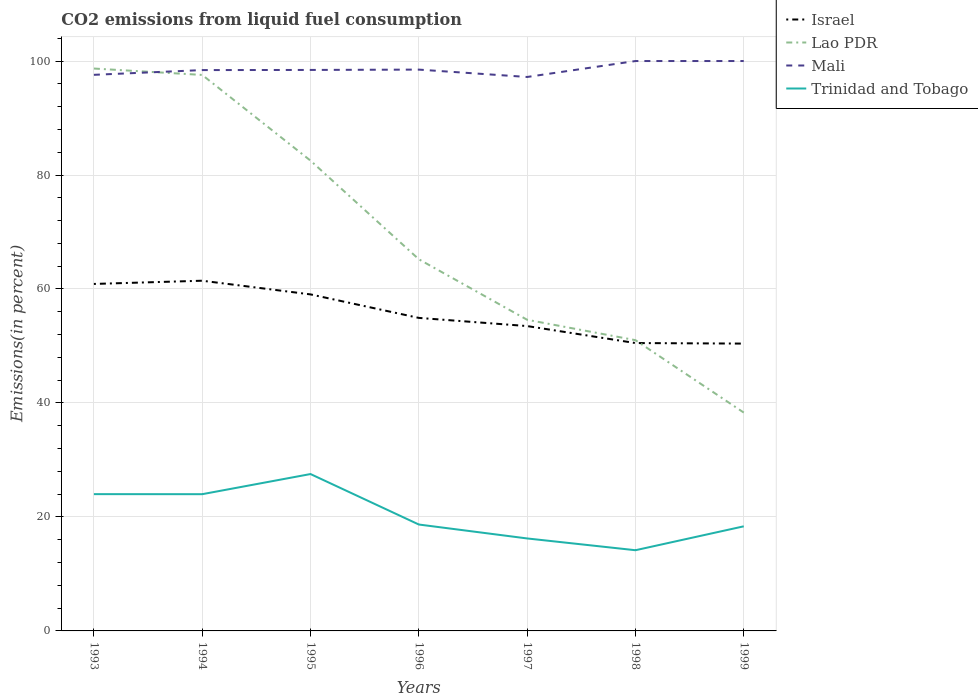How many different coloured lines are there?
Your answer should be very brief. 4. Is the number of lines equal to the number of legend labels?
Keep it short and to the point. Yes. Across all years, what is the maximum total CO2 emitted in Israel?
Provide a succinct answer. 50.42. What is the total total CO2 emitted in Lao PDR in the graph?
Give a very brief answer. 60.37. What is the difference between the highest and the second highest total CO2 emitted in Israel?
Give a very brief answer. 11.03. What is the difference between the highest and the lowest total CO2 emitted in Mali?
Offer a terse response. 2. Is the total CO2 emitted in Lao PDR strictly greater than the total CO2 emitted in Trinidad and Tobago over the years?
Offer a very short reply. No. How many lines are there?
Give a very brief answer. 4. What is the difference between two consecutive major ticks on the Y-axis?
Offer a terse response. 20. Does the graph contain grids?
Provide a succinct answer. Yes. What is the title of the graph?
Your answer should be very brief. CO2 emissions from liquid fuel consumption. Does "Faeroe Islands" appear as one of the legend labels in the graph?
Provide a succinct answer. No. What is the label or title of the Y-axis?
Give a very brief answer. Emissions(in percent). What is the Emissions(in percent) in Israel in 1993?
Your answer should be very brief. 60.89. What is the Emissions(in percent) in Lao PDR in 1993?
Provide a short and direct response. 98.68. What is the Emissions(in percent) in Mali in 1993?
Keep it short and to the point. 97.58. What is the Emissions(in percent) in Trinidad and Tobago in 1993?
Provide a short and direct response. 24. What is the Emissions(in percent) in Israel in 1994?
Give a very brief answer. 61.45. What is the Emissions(in percent) of Lao PDR in 1994?
Your response must be concise. 97.56. What is the Emissions(in percent) of Mali in 1994?
Give a very brief answer. 98.41. What is the Emissions(in percent) in Trinidad and Tobago in 1994?
Offer a very short reply. 23.99. What is the Emissions(in percent) of Israel in 1995?
Give a very brief answer. 59.05. What is the Emissions(in percent) in Lao PDR in 1995?
Keep it short and to the point. 82.52. What is the Emissions(in percent) of Mali in 1995?
Offer a terse response. 98.44. What is the Emissions(in percent) of Trinidad and Tobago in 1995?
Provide a succinct answer. 27.53. What is the Emissions(in percent) of Israel in 1996?
Make the answer very short. 54.93. What is the Emissions(in percent) of Lao PDR in 1996?
Your answer should be very brief. 65.22. What is the Emissions(in percent) in Mali in 1996?
Ensure brevity in your answer.  98.5. What is the Emissions(in percent) in Trinidad and Tobago in 1996?
Offer a very short reply. 18.67. What is the Emissions(in percent) in Israel in 1997?
Give a very brief answer. 53.49. What is the Emissions(in percent) in Lao PDR in 1997?
Offer a terse response. 54.6. What is the Emissions(in percent) of Mali in 1997?
Ensure brevity in your answer.  97.2. What is the Emissions(in percent) of Trinidad and Tobago in 1997?
Offer a very short reply. 16.23. What is the Emissions(in percent) of Israel in 1998?
Ensure brevity in your answer.  50.51. What is the Emissions(in percent) in Lao PDR in 1998?
Offer a terse response. 51.02. What is the Emissions(in percent) in Mali in 1998?
Your response must be concise. 100. What is the Emissions(in percent) of Trinidad and Tobago in 1998?
Provide a short and direct response. 14.16. What is the Emissions(in percent) in Israel in 1999?
Ensure brevity in your answer.  50.42. What is the Emissions(in percent) in Lao PDR in 1999?
Make the answer very short. 38.31. What is the Emissions(in percent) of Trinidad and Tobago in 1999?
Your response must be concise. 18.35. Across all years, what is the maximum Emissions(in percent) in Israel?
Provide a short and direct response. 61.45. Across all years, what is the maximum Emissions(in percent) of Lao PDR?
Your answer should be compact. 98.68. Across all years, what is the maximum Emissions(in percent) of Trinidad and Tobago?
Give a very brief answer. 27.53. Across all years, what is the minimum Emissions(in percent) in Israel?
Provide a succinct answer. 50.42. Across all years, what is the minimum Emissions(in percent) of Lao PDR?
Your answer should be compact. 38.31. Across all years, what is the minimum Emissions(in percent) of Mali?
Your response must be concise. 97.2. Across all years, what is the minimum Emissions(in percent) in Trinidad and Tobago?
Keep it short and to the point. 14.16. What is the total Emissions(in percent) of Israel in the graph?
Provide a succinct answer. 390.74. What is the total Emissions(in percent) in Lao PDR in the graph?
Provide a succinct answer. 487.92. What is the total Emissions(in percent) of Mali in the graph?
Give a very brief answer. 690.13. What is the total Emissions(in percent) of Trinidad and Tobago in the graph?
Provide a short and direct response. 142.94. What is the difference between the Emissions(in percent) of Israel in 1993 and that in 1994?
Your answer should be compact. -0.57. What is the difference between the Emissions(in percent) in Lao PDR in 1993 and that in 1994?
Your answer should be compact. 1.12. What is the difference between the Emissions(in percent) of Mali in 1993 and that in 1994?
Keep it short and to the point. -0.83. What is the difference between the Emissions(in percent) of Trinidad and Tobago in 1993 and that in 1994?
Provide a short and direct response. 0.01. What is the difference between the Emissions(in percent) of Israel in 1993 and that in 1995?
Keep it short and to the point. 1.83. What is the difference between the Emissions(in percent) of Lao PDR in 1993 and that in 1995?
Provide a short and direct response. 16.16. What is the difference between the Emissions(in percent) of Mali in 1993 and that in 1995?
Provide a succinct answer. -0.86. What is the difference between the Emissions(in percent) of Trinidad and Tobago in 1993 and that in 1995?
Offer a terse response. -3.52. What is the difference between the Emissions(in percent) of Israel in 1993 and that in 1996?
Ensure brevity in your answer.  5.96. What is the difference between the Emissions(in percent) in Lao PDR in 1993 and that in 1996?
Your answer should be very brief. 33.47. What is the difference between the Emissions(in percent) of Mali in 1993 and that in 1996?
Keep it short and to the point. -0.92. What is the difference between the Emissions(in percent) of Trinidad and Tobago in 1993 and that in 1996?
Offer a terse response. 5.33. What is the difference between the Emissions(in percent) of Israel in 1993 and that in 1997?
Offer a very short reply. 7.39. What is the difference between the Emissions(in percent) in Lao PDR in 1993 and that in 1997?
Offer a very short reply. 44.09. What is the difference between the Emissions(in percent) in Mali in 1993 and that in 1997?
Offer a very short reply. 0.38. What is the difference between the Emissions(in percent) of Trinidad and Tobago in 1993 and that in 1997?
Give a very brief answer. 7.77. What is the difference between the Emissions(in percent) in Israel in 1993 and that in 1998?
Provide a short and direct response. 10.37. What is the difference between the Emissions(in percent) in Lao PDR in 1993 and that in 1998?
Offer a terse response. 47.66. What is the difference between the Emissions(in percent) of Mali in 1993 and that in 1998?
Your answer should be compact. -2.42. What is the difference between the Emissions(in percent) of Trinidad and Tobago in 1993 and that in 1998?
Your answer should be very brief. 9.84. What is the difference between the Emissions(in percent) of Israel in 1993 and that in 1999?
Keep it short and to the point. 10.47. What is the difference between the Emissions(in percent) in Lao PDR in 1993 and that in 1999?
Keep it short and to the point. 60.37. What is the difference between the Emissions(in percent) in Mali in 1993 and that in 1999?
Keep it short and to the point. -2.42. What is the difference between the Emissions(in percent) of Trinidad and Tobago in 1993 and that in 1999?
Give a very brief answer. 5.65. What is the difference between the Emissions(in percent) of Israel in 1994 and that in 1995?
Your answer should be compact. 2.4. What is the difference between the Emissions(in percent) of Lao PDR in 1994 and that in 1995?
Make the answer very short. 15.04. What is the difference between the Emissions(in percent) in Mali in 1994 and that in 1995?
Provide a succinct answer. -0.02. What is the difference between the Emissions(in percent) of Trinidad and Tobago in 1994 and that in 1995?
Provide a succinct answer. -3.53. What is the difference between the Emissions(in percent) of Israel in 1994 and that in 1996?
Keep it short and to the point. 6.52. What is the difference between the Emissions(in percent) in Lao PDR in 1994 and that in 1996?
Provide a short and direct response. 32.34. What is the difference between the Emissions(in percent) of Mali in 1994 and that in 1996?
Provide a short and direct response. -0.08. What is the difference between the Emissions(in percent) of Trinidad and Tobago in 1994 and that in 1996?
Your answer should be very brief. 5.32. What is the difference between the Emissions(in percent) of Israel in 1994 and that in 1997?
Your answer should be compact. 7.96. What is the difference between the Emissions(in percent) of Lao PDR in 1994 and that in 1997?
Offer a terse response. 42.96. What is the difference between the Emissions(in percent) in Mali in 1994 and that in 1997?
Make the answer very short. 1.21. What is the difference between the Emissions(in percent) of Trinidad and Tobago in 1994 and that in 1997?
Offer a terse response. 7.77. What is the difference between the Emissions(in percent) in Israel in 1994 and that in 1998?
Ensure brevity in your answer.  10.94. What is the difference between the Emissions(in percent) of Lao PDR in 1994 and that in 1998?
Your answer should be very brief. 46.54. What is the difference between the Emissions(in percent) of Mali in 1994 and that in 1998?
Keep it short and to the point. -1.59. What is the difference between the Emissions(in percent) of Trinidad and Tobago in 1994 and that in 1998?
Give a very brief answer. 9.83. What is the difference between the Emissions(in percent) in Israel in 1994 and that in 1999?
Offer a very short reply. 11.03. What is the difference between the Emissions(in percent) of Lao PDR in 1994 and that in 1999?
Provide a short and direct response. 59.25. What is the difference between the Emissions(in percent) in Mali in 1994 and that in 1999?
Provide a short and direct response. -1.59. What is the difference between the Emissions(in percent) in Trinidad and Tobago in 1994 and that in 1999?
Give a very brief answer. 5.64. What is the difference between the Emissions(in percent) of Israel in 1995 and that in 1996?
Give a very brief answer. 4.12. What is the difference between the Emissions(in percent) in Lao PDR in 1995 and that in 1996?
Keep it short and to the point. 17.31. What is the difference between the Emissions(in percent) in Mali in 1995 and that in 1996?
Give a very brief answer. -0.06. What is the difference between the Emissions(in percent) in Trinidad and Tobago in 1995 and that in 1996?
Make the answer very short. 8.86. What is the difference between the Emissions(in percent) in Israel in 1995 and that in 1997?
Give a very brief answer. 5.56. What is the difference between the Emissions(in percent) in Lao PDR in 1995 and that in 1997?
Offer a very short reply. 27.93. What is the difference between the Emissions(in percent) in Mali in 1995 and that in 1997?
Offer a very short reply. 1.23. What is the difference between the Emissions(in percent) of Trinidad and Tobago in 1995 and that in 1997?
Your response must be concise. 11.3. What is the difference between the Emissions(in percent) in Israel in 1995 and that in 1998?
Your response must be concise. 8.54. What is the difference between the Emissions(in percent) of Lao PDR in 1995 and that in 1998?
Provide a short and direct response. 31.5. What is the difference between the Emissions(in percent) of Mali in 1995 and that in 1998?
Provide a succinct answer. -1.56. What is the difference between the Emissions(in percent) of Trinidad and Tobago in 1995 and that in 1998?
Keep it short and to the point. 13.37. What is the difference between the Emissions(in percent) of Israel in 1995 and that in 1999?
Offer a very short reply. 8.63. What is the difference between the Emissions(in percent) in Lao PDR in 1995 and that in 1999?
Your answer should be compact. 44.21. What is the difference between the Emissions(in percent) of Mali in 1995 and that in 1999?
Your answer should be compact. -1.56. What is the difference between the Emissions(in percent) of Trinidad and Tobago in 1995 and that in 1999?
Ensure brevity in your answer.  9.17. What is the difference between the Emissions(in percent) of Israel in 1996 and that in 1997?
Give a very brief answer. 1.43. What is the difference between the Emissions(in percent) in Lao PDR in 1996 and that in 1997?
Provide a short and direct response. 10.62. What is the difference between the Emissions(in percent) of Mali in 1996 and that in 1997?
Keep it short and to the point. 1.29. What is the difference between the Emissions(in percent) in Trinidad and Tobago in 1996 and that in 1997?
Provide a succinct answer. 2.44. What is the difference between the Emissions(in percent) in Israel in 1996 and that in 1998?
Your response must be concise. 4.41. What is the difference between the Emissions(in percent) in Lao PDR in 1996 and that in 1998?
Keep it short and to the point. 14.2. What is the difference between the Emissions(in percent) in Mali in 1996 and that in 1998?
Offer a very short reply. -1.5. What is the difference between the Emissions(in percent) in Trinidad and Tobago in 1996 and that in 1998?
Provide a succinct answer. 4.51. What is the difference between the Emissions(in percent) in Israel in 1996 and that in 1999?
Ensure brevity in your answer.  4.51. What is the difference between the Emissions(in percent) of Lao PDR in 1996 and that in 1999?
Make the answer very short. 26.9. What is the difference between the Emissions(in percent) of Mali in 1996 and that in 1999?
Provide a short and direct response. -1.5. What is the difference between the Emissions(in percent) of Trinidad and Tobago in 1996 and that in 1999?
Provide a succinct answer. 0.32. What is the difference between the Emissions(in percent) in Israel in 1997 and that in 1998?
Give a very brief answer. 2.98. What is the difference between the Emissions(in percent) of Lao PDR in 1997 and that in 1998?
Provide a short and direct response. 3.58. What is the difference between the Emissions(in percent) of Mali in 1997 and that in 1998?
Make the answer very short. -2.8. What is the difference between the Emissions(in percent) of Trinidad and Tobago in 1997 and that in 1998?
Keep it short and to the point. 2.07. What is the difference between the Emissions(in percent) of Israel in 1997 and that in 1999?
Ensure brevity in your answer.  3.08. What is the difference between the Emissions(in percent) in Lao PDR in 1997 and that in 1999?
Provide a succinct answer. 16.28. What is the difference between the Emissions(in percent) of Mali in 1997 and that in 1999?
Your answer should be compact. -2.8. What is the difference between the Emissions(in percent) of Trinidad and Tobago in 1997 and that in 1999?
Your answer should be very brief. -2.13. What is the difference between the Emissions(in percent) of Israel in 1998 and that in 1999?
Keep it short and to the point. 0.1. What is the difference between the Emissions(in percent) of Lao PDR in 1998 and that in 1999?
Provide a succinct answer. 12.71. What is the difference between the Emissions(in percent) in Trinidad and Tobago in 1998 and that in 1999?
Provide a succinct answer. -4.19. What is the difference between the Emissions(in percent) of Israel in 1993 and the Emissions(in percent) of Lao PDR in 1994?
Ensure brevity in your answer.  -36.68. What is the difference between the Emissions(in percent) of Israel in 1993 and the Emissions(in percent) of Mali in 1994?
Your response must be concise. -37.53. What is the difference between the Emissions(in percent) in Israel in 1993 and the Emissions(in percent) in Trinidad and Tobago in 1994?
Offer a terse response. 36.89. What is the difference between the Emissions(in percent) of Lao PDR in 1993 and the Emissions(in percent) of Mali in 1994?
Provide a short and direct response. 0.27. What is the difference between the Emissions(in percent) in Lao PDR in 1993 and the Emissions(in percent) in Trinidad and Tobago in 1994?
Ensure brevity in your answer.  74.69. What is the difference between the Emissions(in percent) in Mali in 1993 and the Emissions(in percent) in Trinidad and Tobago in 1994?
Give a very brief answer. 73.59. What is the difference between the Emissions(in percent) of Israel in 1993 and the Emissions(in percent) of Lao PDR in 1995?
Provide a short and direct response. -21.64. What is the difference between the Emissions(in percent) in Israel in 1993 and the Emissions(in percent) in Mali in 1995?
Your answer should be compact. -37.55. What is the difference between the Emissions(in percent) of Israel in 1993 and the Emissions(in percent) of Trinidad and Tobago in 1995?
Offer a very short reply. 33.36. What is the difference between the Emissions(in percent) in Lao PDR in 1993 and the Emissions(in percent) in Mali in 1995?
Offer a terse response. 0.25. What is the difference between the Emissions(in percent) of Lao PDR in 1993 and the Emissions(in percent) of Trinidad and Tobago in 1995?
Provide a succinct answer. 71.16. What is the difference between the Emissions(in percent) in Mali in 1993 and the Emissions(in percent) in Trinidad and Tobago in 1995?
Keep it short and to the point. 70.05. What is the difference between the Emissions(in percent) in Israel in 1993 and the Emissions(in percent) in Lao PDR in 1996?
Offer a terse response. -4.33. What is the difference between the Emissions(in percent) of Israel in 1993 and the Emissions(in percent) of Mali in 1996?
Provide a succinct answer. -37.61. What is the difference between the Emissions(in percent) in Israel in 1993 and the Emissions(in percent) in Trinidad and Tobago in 1996?
Provide a short and direct response. 42.22. What is the difference between the Emissions(in percent) in Lao PDR in 1993 and the Emissions(in percent) in Mali in 1996?
Provide a short and direct response. 0.19. What is the difference between the Emissions(in percent) in Lao PDR in 1993 and the Emissions(in percent) in Trinidad and Tobago in 1996?
Provide a succinct answer. 80.01. What is the difference between the Emissions(in percent) in Mali in 1993 and the Emissions(in percent) in Trinidad and Tobago in 1996?
Keep it short and to the point. 78.91. What is the difference between the Emissions(in percent) of Israel in 1993 and the Emissions(in percent) of Lao PDR in 1997?
Make the answer very short. 6.29. What is the difference between the Emissions(in percent) in Israel in 1993 and the Emissions(in percent) in Mali in 1997?
Keep it short and to the point. -36.32. What is the difference between the Emissions(in percent) of Israel in 1993 and the Emissions(in percent) of Trinidad and Tobago in 1997?
Offer a very short reply. 44.66. What is the difference between the Emissions(in percent) in Lao PDR in 1993 and the Emissions(in percent) in Mali in 1997?
Your response must be concise. 1.48. What is the difference between the Emissions(in percent) of Lao PDR in 1993 and the Emissions(in percent) of Trinidad and Tobago in 1997?
Keep it short and to the point. 82.46. What is the difference between the Emissions(in percent) of Mali in 1993 and the Emissions(in percent) of Trinidad and Tobago in 1997?
Make the answer very short. 81.35. What is the difference between the Emissions(in percent) of Israel in 1993 and the Emissions(in percent) of Lao PDR in 1998?
Offer a terse response. 9.87. What is the difference between the Emissions(in percent) in Israel in 1993 and the Emissions(in percent) in Mali in 1998?
Your response must be concise. -39.11. What is the difference between the Emissions(in percent) of Israel in 1993 and the Emissions(in percent) of Trinidad and Tobago in 1998?
Provide a succinct answer. 46.72. What is the difference between the Emissions(in percent) in Lao PDR in 1993 and the Emissions(in percent) in Mali in 1998?
Your answer should be very brief. -1.32. What is the difference between the Emissions(in percent) in Lao PDR in 1993 and the Emissions(in percent) in Trinidad and Tobago in 1998?
Make the answer very short. 84.52. What is the difference between the Emissions(in percent) of Mali in 1993 and the Emissions(in percent) of Trinidad and Tobago in 1998?
Offer a very short reply. 83.42. What is the difference between the Emissions(in percent) of Israel in 1993 and the Emissions(in percent) of Lao PDR in 1999?
Provide a short and direct response. 22.57. What is the difference between the Emissions(in percent) in Israel in 1993 and the Emissions(in percent) in Mali in 1999?
Ensure brevity in your answer.  -39.11. What is the difference between the Emissions(in percent) of Israel in 1993 and the Emissions(in percent) of Trinidad and Tobago in 1999?
Offer a very short reply. 42.53. What is the difference between the Emissions(in percent) in Lao PDR in 1993 and the Emissions(in percent) in Mali in 1999?
Offer a terse response. -1.32. What is the difference between the Emissions(in percent) in Lao PDR in 1993 and the Emissions(in percent) in Trinidad and Tobago in 1999?
Keep it short and to the point. 80.33. What is the difference between the Emissions(in percent) of Mali in 1993 and the Emissions(in percent) of Trinidad and Tobago in 1999?
Make the answer very short. 79.23. What is the difference between the Emissions(in percent) in Israel in 1994 and the Emissions(in percent) in Lao PDR in 1995?
Ensure brevity in your answer.  -21.07. What is the difference between the Emissions(in percent) in Israel in 1994 and the Emissions(in percent) in Mali in 1995?
Keep it short and to the point. -36.99. What is the difference between the Emissions(in percent) in Israel in 1994 and the Emissions(in percent) in Trinidad and Tobago in 1995?
Provide a succinct answer. 33.92. What is the difference between the Emissions(in percent) in Lao PDR in 1994 and the Emissions(in percent) in Mali in 1995?
Your answer should be very brief. -0.88. What is the difference between the Emissions(in percent) in Lao PDR in 1994 and the Emissions(in percent) in Trinidad and Tobago in 1995?
Provide a succinct answer. 70.03. What is the difference between the Emissions(in percent) in Mali in 1994 and the Emissions(in percent) in Trinidad and Tobago in 1995?
Your answer should be very brief. 70.89. What is the difference between the Emissions(in percent) in Israel in 1994 and the Emissions(in percent) in Lao PDR in 1996?
Keep it short and to the point. -3.77. What is the difference between the Emissions(in percent) in Israel in 1994 and the Emissions(in percent) in Mali in 1996?
Offer a terse response. -37.04. What is the difference between the Emissions(in percent) of Israel in 1994 and the Emissions(in percent) of Trinidad and Tobago in 1996?
Keep it short and to the point. 42.78. What is the difference between the Emissions(in percent) of Lao PDR in 1994 and the Emissions(in percent) of Mali in 1996?
Give a very brief answer. -0.94. What is the difference between the Emissions(in percent) in Lao PDR in 1994 and the Emissions(in percent) in Trinidad and Tobago in 1996?
Your answer should be very brief. 78.89. What is the difference between the Emissions(in percent) in Mali in 1994 and the Emissions(in percent) in Trinidad and Tobago in 1996?
Ensure brevity in your answer.  79.74. What is the difference between the Emissions(in percent) in Israel in 1994 and the Emissions(in percent) in Lao PDR in 1997?
Ensure brevity in your answer.  6.85. What is the difference between the Emissions(in percent) of Israel in 1994 and the Emissions(in percent) of Mali in 1997?
Offer a very short reply. -35.75. What is the difference between the Emissions(in percent) of Israel in 1994 and the Emissions(in percent) of Trinidad and Tobago in 1997?
Provide a short and direct response. 45.22. What is the difference between the Emissions(in percent) of Lao PDR in 1994 and the Emissions(in percent) of Mali in 1997?
Give a very brief answer. 0.36. What is the difference between the Emissions(in percent) of Lao PDR in 1994 and the Emissions(in percent) of Trinidad and Tobago in 1997?
Your answer should be very brief. 81.33. What is the difference between the Emissions(in percent) of Mali in 1994 and the Emissions(in percent) of Trinidad and Tobago in 1997?
Ensure brevity in your answer.  82.18. What is the difference between the Emissions(in percent) in Israel in 1994 and the Emissions(in percent) in Lao PDR in 1998?
Make the answer very short. 10.43. What is the difference between the Emissions(in percent) in Israel in 1994 and the Emissions(in percent) in Mali in 1998?
Provide a succinct answer. -38.55. What is the difference between the Emissions(in percent) of Israel in 1994 and the Emissions(in percent) of Trinidad and Tobago in 1998?
Keep it short and to the point. 47.29. What is the difference between the Emissions(in percent) in Lao PDR in 1994 and the Emissions(in percent) in Mali in 1998?
Your response must be concise. -2.44. What is the difference between the Emissions(in percent) of Lao PDR in 1994 and the Emissions(in percent) of Trinidad and Tobago in 1998?
Make the answer very short. 83.4. What is the difference between the Emissions(in percent) of Mali in 1994 and the Emissions(in percent) of Trinidad and Tobago in 1998?
Your response must be concise. 84.25. What is the difference between the Emissions(in percent) of Israel in 1994 and the Emissions(in percent) of Lao PDR in 1999?
Offer a terse response. 23.14. What is the difference between the Emissions(in percent) of Israel in 1994 and the Emissions(in percent) of Mali in 1999?
Your response must be concise. -38.55. What is the difference between the Emissions(in percent) in Israel in 1994 and the Emissions(in percent) in Trinidad and Tobago in 1999?
Keep it short and to the point. 43.1. What is the difference between the Emissions(in percent) of Lao PDR in 1994 and the Emissions(in percent) of Mali in 1999?
Give a very brief answer. -2.44. What is the difference between the Emissions(in percent) in Lao PDR in 1994 and the Emissions(in percent) in Trinidad and Tobago in 1999?
Make the answer very short. 79.21. What is the difference between the Emissions(in percent) of Mali in 1994 and the Emissions(in percent) of Trinidad and Tobago in 1999?
Your response must be concise. 80.06. What is the difference between the Emissions(in percent) of Israel in 1995 and the Emissions(in percent) of Lao PDR in 1996?
Provide a short and direct response. -6.17. What is the difference between the Emissions(in percent) of Israel in 1995 and the Emissions(in percent) of Mali in 1996?
Offer a very short reply. -39.45. What is the difference between the Emissions(in percent) in Israel in 1995 and the Emissions(in percent) in Trinidad and Tobago in 1996?
Provide a succinct answer. 40.38. What is the difference between the Emissions(in percent) of Lao PDR in 1995 and the Emissions(in percent) of Mali in 1996?
Make the answer very short. -15.97. What is the difference between the Emissions(in percent) of Lao PDR in 1995 and the Emissions(in percent) of Trinidad and Tobago in 1996?
Your response must be concise. 63.85. What is the difference between the Emissions(in percent) of Mali in 1995 and the Emissions(in percent) of Trinidad and Tobago in 1996?
Provide a succinct answer. 79.77. What is the difference between the Emissions(in percent) of Israel in 1995 and the Emissions(in percent) of Lao PDR in 1997?
Keep it short and to the point. 4.45. What is the difference between the Emissions(in percent) in Israel in 1995 and the Emissions(in percent) in Mali in 1997?
Your response must be concise. -38.15. What is the difference between the Emissions(in percent) in Israel in 1995 and the Emissions(in percent) in Trinidad and Tobago in 1997?
Provide a succinct answer. 42.82. What is the difference between the Emissions(in percent) in Lao PDR in 1995 and the Emissions(in percent) in Mali in 1997?
Provide a succinct answer. -14.68. What is the difference between the Emissions(in percent) in Lao PDR in 1995 and the Emissions(in percent) in Trinidad and Tobago in 1997?
Give a very brief answer. 66.3. What is the difference between the Emissions(in percent) of Mali in 1995 and the Emissions(in percent) of Trinidad and Tobago in 1997?
Give a very brief answer. 82.21. What is the difference between the Emissions(in percent) of Israel in 1995 and the Emissions(in percent) of Lao PDR in 1998?
Offer a terse response. 8.03. What is the difference between the Emissions(in percent) of Israel in 1995 and the Emissions(in percent) of Mali in 1998?
Give a very brief answer. -40.95. What is the difference between the Emissions(in percent) of Israel in 1995 and the Emissions(in percent) of Trinidad and Tobago in 1998?
Provide a short and direct response. 44.89. What is the difference between the Emissions(in percent) in Lao PDR in 1995 and the Emissions(in percent) in Mali in 1998?
Provide a succinct answer. -17.48. What is the difference between the Emissions(in percent) in Lao PDR in 1995 and the Emissions(in percent) in Trinidad and Tobago in 1998?
Provide a succinct answer. 68.36. What is the difference between the Emissions(in percent) of Mali in 1995 and the Emissions(in percent) of Trinidad and Tobago in 1998?
Offer a terse response. 84.28. What is the difference between the Emissions(in percent) in Israel in 1995 and the Emissions(in percent) in Lao PDR in 1999?
Make the answer very short. 20.74. What is the difference between the Emissions(in percent) of Israel in 1995 and the Emissions(in percent) of Mali in 1999?
Make the answer very short. -40.95. What is the difference between the Emissions(in percent) of Israel in 1995 and the Emissions(in percent) of Trinidad and Tobago in 1999?
Offer a terse response. 40.7. What is the difference between the Emissions(in percent) in Lao PDR in 1995 and the Emissions(in percent) in Mali in 1999?
Keep it short and to the point. -17.48. What is the difference between the Emissions(in percent) of Lao PDR in 1995 and the Emissions(in percent) of Trinidad and Tobago in 1999?
Offer a terse response. 64.17. What is the difference between the Emissions(in percent) in Mali in 1995 and the Emissions(in percent) in Trinidad and Tobago in 1999?
Provide a succinct answer. 80.08. What is the difference between the Emissions(in percent) of Israel in 1996 and the Emissions(in percent) of Lao PDR in 1997?
Offer a terse response. 0.33. What is the difference between the Emissions(in percent) of Israel in 1996 and the Emissions(in percent) of Mali in 1997?
Provide a succinct answer. -42.28. What is the difference between the Emissions(in percent) in Israel in 1996 and the Emissions(in percent) in Trinidad and Tobago in 1997?
Your response must be concise. 38.7. What is the difference between the Emissions(in percent) in Lao PDR in 1996 and the Emissions(in percent) in Mali in 1997?
Your response must be concise. -31.99. What is the difference between the Emissions(in percent) of Lao PDR in 1996 and the Emissions(in percent) of Trinidad and Tobago in 1997?
Give a very brief answer. 48.99. What is the difference between the Emissions(in percent) in Mali in 1996 and the Emissions(in percent) in Trinidad and Tobago in 1997?
Provide a succinct answer. 82.27. What is the difference between the Emissions(in percent) in Israel in 1996 and the Emissions(in percent) in Lao PDR in 1998?
Provide a short and direct response. 3.91. What is the difference between the Emissions(in percent) of Israel in 1996 and the Emissions(in percent) of Mali in 1998?
Make the answer very short. -45.07. What is the difference between the Emissions(in percent) in Israel in 1996 and the Emissions(in percent) in Trinidad and Tobago in 1998?
Offer a terse response. 40.77. What is the difference between the Emissions(in percent) in Lao PDR in 1996 and the Emissions(in percent) in Mali in 1998?
Your response must be concise. -34.78. What is the difference between the Emissions(in percent) in Lao PDR in 1996 and the Emissions(in percent) in Trinidad and Tobago in 1998?
Offer a terse response. 51.06. What is the difference between the Emissions(in percent) in Mali in 1996 and the Emissions(in percent) in Trinidad and Tobago in 1998?
Make the answer very short. 84.34. What is the difference between the Emissions(in percent) of Israel in 1996 and the Emissions(in percent) of Lao PDR in 1999?
Ensure brevity in your answer.  16.61. What is the difference between the Emissions(in percent) in Israel in 1996 and the Emissions(in percent) in Mali in 1999?
Offer a very short reply. -45.07. What is the difference between the Emissions(in percent) in Israel in 1996 and the Emissions(in percent) in Trinidad and Tobago in 1999?
Your response must be concise. 36.57. What is the difference between the Emissions(in percent) in Lao PDR in 1996 and the Emissions(in percent) in Mali in 1999?
Your response must be concise. -34.78. What is the difference between the Emissions(in percent) of Lao PDR in 1996 and the Emissions(in percent) of Trinidad and Tobago in 1999?
Ensure brevity in your answer.  46.86. What is the difference between the Emissions(in percent) of Mali in 1996 and the Emissions(in percent) of Trinidad and Tobago in 1999?
Your answer should be compact. 80.14. What is the difference between the Emissions(in percent) of Israel in 1997 and the Emissions(in percent) of Lao PDR in 1998?
Provide a succinct answer. 2.47. What is the difference between the Emissions(in percent) of Israel in 1997 and the Emissions(in percent) of Mali in 1998?
Give a very brief answer. -46.51. What is the difference between the Emissions(in percent) of Israel in 1997 and the Emissions(in percent) of Trinidad and Tobago in 1998?
Make the answer very short. 39.33. What is the difference between the Emissions(in percent) in Lao PDR in 1997 and the Emissions(in percent) in Mali in 1998?
Keep it short and to the point. -45.4. What is the difference between the Emissions(in percent) of Lao PDR in 1997 and the Emissions(in percent) of Trinidad and Tobago in 1998?
Offer a very short reply. 40.44. What is the difference between the Emissions(in percent) in Mali in 1997 and the Emissions(in percent) in Trinidad and Tobago in 1998?
Offer a terse response. 83.04. What is the difference between the Emissions(in percent) in Israel in 1997 and the Emissions(in percent) in Lao PDR in 1999?
Provide a succinct answer. 15.18. What is the difference between the Emissions(in percent) in Israel in 1997 and the Emissions(in percent) in Mali in 1999?
Provide a succinct answer. -46.51. What is the difference between the Emissions(in percent) of Israel in 1997 and the Emissions(in percent) of Trinidad and Tobago in 1999?
Provide a short and direct response. 35.14. What is the difference between the Emissions(in percent) of Lao PDR in 1997 and the Emissions(in percent) of Mali in 1999?
Give a very brief answer. -45.4. What is the difference between the Emissions(in percent) in Lao PDR in 1997 and the Emissions(in percent) in Trinidad and Tobago in 1999?
Provide a short and direct response. 36.24. What is the difference between the Emissions(in percent) in Mali in 1997 and the Emissions(in percent) in Trinidad and Tobago in 1999?
Give a very brief answer. 78.85. What is the difference between the Emissions(in percent) in Israel in 1998 and the Emissions(in percent) in Lao PDR in 1999?
Provide a succinct answer. 12.2. What is the difference between the Emissions(in percent) in Israel in 1998 and the Emissions(in percent) in Mali in 1999?
Give a very brief answer. -49.49. What is the difference between the Emissions(in percent) of Israel in 1998 and the Emissions(in percent) of Trinidad and Tobago in 1999?
Your answer should be compact. 32.16. What is the difference between the Emissions(in percent) of Lao PDR in 1998 and the Emissions(in percent) of Mali in 1999?
Keep it short and to the point. -48.98. What is the difference between the Emissions(in percent) of Lao PDR in 1998 and the Emissions(in percent) of Trinidad and Tobago in 1999?
Make the answer very short. 32.67. What is the difference between the Emissions(in percent) in Mali in 1998 and the Emissions(in percent) in Trinidad and Tobago in 1999?
Ensure brevity in your answer.  81.65. What is the average Emissions(in percent) in Israel per year?
Offer a terse response. 55.82. What is the average Emissions(in percent) in Lao PDR per year?
Provide a short and direct response. 69.7. What is the average Emissions(in percent) of Mali per year?
Ensure brevity in your answer.  98.59. What is the average Emissions(in percent) of Trinidad and Tobago per year?
Ensure brevity in your answer.  20.42. In the year 1993, what is the difference between the Emissions(in percent) of Israel and Emissions(in percent) of Lao PDR?
Keep it short and to the point. -37.8. In the year 1993, what is the difference between the Emissions(in percent) in Israel and Emissions(in percent) in Mali?
Your answer should be very brief. -36.7. In the year 1993, what is the difference between the Emissions(in percent) of Israel and Emissions(in percent) of Trinidad and Tobago?
Make the answer very short. 36.88. In the year 1993, what is the difference between the Emissions(in percent) of Lao PDR and Emissions(in percent) of Mali?
Your response must be concise. 1.1. In the year 1993, what is the difference between the Emissions(in percent) of Lao PDR and Emissions(in percent) of Trinidad and Tobago?
Provide a short and direct response. 74.68. In the year 1993, what is the difference between the Emissions(in percent) of Mali and Emissions(in percent) of Trinidad and Tobago?
Offer a very short reply. 73.58. In the year 1994, what is the difference between the Emissions(in percent) of Israel and Emissions(in percent) of Lao PDR?
Offer a terse response. -36.11. In the year 1994, what is the difference between the Emissions(in percent) in Israel and Emissions(in percent) in Mali?
Give a very brief answer. -36.96. In the year 1994, what is the difference between the Emissions(in percent) of Israel and Emissions(in percent) of Trinidad and Tobago?
Offer a very short reply. 37.46. In the year 1994, what is the difference between the Emissions(in percent) in Lao PDR and Emissions(in percent) in Mali?
Make the answer very short. -0.85. In the year 1994, what is the difference between the Emissions(in percent) of Lao PDR and Emissions(in percent) of Trinidad and Tobago?
Your response must be concise. 73.57. In the year 1994, what is the difference between the Emissions(in percent) in Mali and Emissions(in percent) in Trinidad and Tobago?
Your response must be concise. 74.42. In the year 1995, what is the difference between the Emissions(in percent) of Israel and Emissions(in percent) of Lao PDR?
Your answer should be very brief. -23.47. In the year 1995, what is the difference between the Emissions(in percent) in Israel and Emissions(in percent) in Mali?
Provide a short and direct response. -39.39. In the year 1995, what is the difference between the Emissions(in percent) in Israel and Emissions(in percent) in Trinidad and Tobago?
Provide a succinct answer. 31.52. In the year 1995, what is the difference between the Emissions(in percent) of Lao PDR and Emissions(in percent) of Mali?
Your response must be concise. -15.91. In the year 1995, what is the difference between the Emissions(in percent) of Lao PDR and Emissions(in percent) of Trinidad and Tobago?
Offer a very short reply. 55. In the year 1995, what is the difference between the Emissions(in percent) of Mali and Emissions(in percent) of Trinidad and Tobago?
Offer a very short reply. 70.91. In the year 1996, what is the difference between the Emissions(in percent) of Israel and Emissions(in percent) of Lao PDR?
Offer a terse response. -10.29. In the year 1996, what is the difference between the Emissions(in percent) of Israel and Emissions(in percent) of Mali?
Your answer should be compact. -43.57. In the year 1996, what is the difference between the Emissions(in percent) in Israel and Emissions(in percent) in Trinidad and Tobago?
Your response must be concise. 36.26. In the year 1996, what is the difference between the Emissions(in percent) in Lao PDR and Emissions(in percent) in Mali?
Provide a succinct answer. -33.28. In the year 1996, what is the difference between the Emissions(in percent) of Lao PDR and Emissions(in percent) of Trinidad and Tobago?
Keep it short and to the point. 46.55. In the year 1996, what is the difference between the Emissions(in percent) in Mali and Emissions(in percent) in Trinidad and Tobago?
Make the answer very short. 79.83. In the year 1997, what is the difference between the Emissions(in percent) of Israel and Emissions(in percent) of Lao PDR?
Your answer should be very brief. -1.1. In the year 1997, what is the difference between the Emissions(in percent) in Israel and Emissions(in percent) in Mali?
Your answer should be compact. -43.71. In the year 1997, what is the difference between the Emissions(in percent) in Israel and Emissions(in percent) in Trinidad and Tobago?
Keep it short and to the point. 37.27. In the year 1997, what is the difference between the Emissions(in percent) in Lao PDR and Emissions(in percent) in Mali?
Your answer should be compact. -42.61. In the year 1997, what is the difference between the Emissions(in percent) in Lao PDR and Emissions(in percent) in Trinidad and Tobago?
Keep it short and to the point. 38.37. In the year 1997, what is the difference between the Emissions(in percent) in Mali and Emissions(in percent) in Trinidad and Tobago?
Offer a very short reply. 80.97. In the year 1998, what is the difference between the Emissions(in percent) of Israel and Emissions(in percent) of Lao PDR?
Offer a very short reply. -0.51. In the year 1998, what is the difference between the Emissions(in percent) of Israel and Emissions(in percent) of Mali?
Provide a short and direct response. -49.49. In the year 1998, what is the difference between the Emissions(in percent) in Israel and Emissions(in percent) in Trinidad and Tobago?
Provide a short and direct response. 36.35. In the year 1998, what is the difference between the Emissions(in percent) in Lao PDR and Emissions(in percent) in Mali?
Give a very brief answer. -48.98. In the year 1998, what is the difference between the Emissions(in percent) in Lao PDR and Emissions(in percent) in Trinidad and Tobago?
Your answer should be compact. 36.86. In the year 1998, what is the difference between the Emissions(in percent) in Mali and Emissions(in percent) in Trinidad and Tobago?
Offer a terse response. 85.84. In the year 1999, what is the difference between the Emissions(in percent) of Israel and Emissions(in percent) of Lao PDR?
Provide a short and direct response. 12.1. In the year 1999, what is the difference between the Emissions(in percent) of Israel and Emissions(in percent) of Mali?
Offer a terse response. -49.58. In the year 1999, what is the difference between the Emissions(in percent) of Israel and Emissions(in percent) of Trinidad and Tobago?
Provide a succinct answer. 32.06. In the year 1999, what is the difference between the Emissions(in percent) of Lao PDR and Emissions(in percent) of Mali?
Your response must be concise. -61.69. In the year 1999, what is the difference between the Emissions(in percent) in Lao PDR and Emissions(in percent) in Trinidad and Tobago?
Offer a terse response. 19.96. In the year 1999, what is the difference between the Emissions(in percent) of Mali and Emissions(in percent) of Trinidad and Tobago?
Your answer should be very brief. 81.65. What is the ratio of the Emissions(in percent) in Lao PDR in 1993 to that in 1994?
Keep it short and to the point. 1.01. What is the ratio of the Emissions(in percent) of Mali in 1993 to that in 1994?
Offer a very short reply. 0.99. What is the ratio of the Emissions(in percent) in Israel in 1993 to that in 1995?
Your answer should be compact. 1.03. What is the ratio of the Emissions(in percent) in Lao PDR in 1993 to that in 1995?
Offer a very short reply. 1.2. What is the ratio of the Emissions(in percent) of Mali in 1993 to that in 1995?
Provide a short and direct response. 0.99. What is the ratio of the Emissions(in percent) in Trinidad and Tobago in 1993 to that in 1995?
Ensure brevity in your answer.  0.87. What is the ratio of the Emissions(in percent) in Israel in 1993 to that in 1996?
Make the answer very short. 1.11. What is the ratio of the Emissions(in percent) of Lao PDR in 1993 to that in 1996?
Your answer should be very brief. 1.51. What is the ratio of the Emissions(in percent) of Mali in 1993 to that in 1996?
Your response must be concise. 0.99. What is the ratio of the Emissions(in percent) of Trinidad and Tobago in 1993 to that in 1996?
Keep it short and to the point. 1.29. What is the ratio of the Emissions(in percent) in Israel in 1993 to that in 1997?
Your answer should be very brief. 1.14. What is the ratio of the Emissions(in percent) of Lao PDR in 1993 to that in 1997?
Your answer should be compact. 1.81. What is the ratio of the Emissions(in percent) in Mali in 1993 to that in 1997?
Offer a terse response. 1. What is the ratio of the Emissions(in percent) in Trinidad and Tobago in 1993 to that in 1997?
Provide a succinct answer. 1.48. What is the ratio of the Emissions(in percent) in Israel in 1993 to that in 1998?
Your response must be concise. 1.21. What is the ratio of the Emissions(in percent) of Lao PDR in 1993 to that in 1998?
Your answer should be very brief. 1.93. What is the ratio of the Emissions(in percent) in Mali in 1993 to that in 1998?
Your response must be concise. 0.98. What is the ratio of the Emissions(in percent) in Trinidad and Tobago in 1993 to that in 1998?
Offer a terse response. 1.7. What is the ratio of the Emissions(in percent) of Israel in 1993 to that in 1999?
Give a very brief answer. 1.21. What is the ratio of the Emissions(in percent) in Lao PDR in 1993 to that in 1999?
Ensure brevity in your answer.  2.58. What is the ratio of the Emissions(in percent) in Mali in 1993 to that in 1999?
Provide a succinct answer. 0.98. What is the ratio of the Emissions(in percent) in Trinidad and Tobago in 1993 to that in 1999?
Offer a terse response. 1.31. What is the ratio of the Emissions(in percent) in Israel in 1994 to that in 1995?
Provide a short and direct response. 1.04. What is the ratio of the Emissions(in percent) in Lao PDR in 1994 to that in 1995?
Your response must be concise. 1.18. What is the ratio of the Emissions(in percent) in Mali in 1994 to that in 1995?
Offer a very short reply. 1. What is the ratio of the Emissions(in percent) in Trinidad and Tobago in 1994 to that in 1995?
Provide a succinct answer. 0.87. What is the ratio of the Emissions(in percent) in Israel in 1994 to that in 1996?
Give a very brief answer. 1.12. What is the ratio of the Emissions(in percent) in Lao PDR in 1994 to that in 1996?
Keep it short and to the point. 1.5. What is the ratio of the Emissions(in percent) in Mali in 1994 to that in 1996?
Ensure brevity in your answer.  1. What is the ratio of the Emissions(in percent) of Trinidad and Tobago in 1994 to that in 1996?
Ensure brevity in your answer.  1.29. What is the ratio of the Emissions(in percent) in Israel in 1994 to that in 1997?
Provide a succinct answer. 1.15. What is the ratio of the Emissions(in percent) of Lao PDR in 1994 to that in 1997?
Provide a succinct answer. 1.79. What is the ratio of the Emissions(in percent) of Mali in 1994 to that in 1997?
Make the answer very short. 1.01. What is the ratio of the Emissions(in percent) of Trinidad and Tobago in 1994 to that in 1997?
Give a very brief answer. 1.48. What is the ratio of the Emissions(in percent) of Israel in 1994 to that in 1998?
Provide a succinct answer. 1.22. What is the ratio of the Emissions(in percent) of Lao PDR in 1994 to that in 1998?
Make the answer very short. 1.91. What is the ratio of the Emissions(in percent) in Mali in 1994 to that in 1998?
Your response must be concise. 0.98. What is the ratio of the Emissions(in percent) of Trinidad and Tobago in 1994 to that in 1998?
Offer a terse response. 1.69. What is the ratio of the Emissions(in percent) in Israel in 1994 to that in 1999?
Ensure brevity in your answer.  1.22. What is the ratio of the Emissions(in percent) in Lao PDR in 1994 to that in 1999?
Provide a succinct answer. 2.55. What is the ratio of the Emissions(in percent) of Mali in 1994 to that in 1999?
Ensure brevity in your answer.  0.98. What is the ratio of the Emissions(in percent) of Trinidad and Tobago in 1994 to that in 1999?
Your answer should be very brief. 1.31. What is the ratio of the Emissions(in percent) of Israel in 1995 to that in 1996?
Offer a terse response. 1.08. What is the ratio of the Emissions(in percent) of Lao PDR in 1995 to that in 1996?
Your answer should be very brief. 1.27. What is the ratio of the Emissions(in percent) of Trinidad and Tobago in 1995 to that in 1996?
Provide a short and direct response. 1.47. What is the ratio of the Emissions(in percent) of Israel in 1995 to that in 1997?
Provide a short and direct response. 1.1. What is the ratio of the Emissions(in percent) in Lao PDR in 1995 to that in 1997?
Your response must be concise. 1.51. What is the ratio of the Emissions(in percent) in Mali in 1995 to that in 1997?
Offer a very short reply. 1.01. What is the ratio of the Emissions(in percent) of Trinidad and Tobago in 1995 to that in 1997?
Your response must be concise. 1.7. What is the ratio of the Emissions(in percent) of Israel in 1995 to that in 1998?
Your answer should be compact. 1.17. What is the ratio of the Emissions(in percent) of Lao PDR in 1995 to that in 1998?
Provide a succinct answer. 1.62. What is the ratio of the Emissions(in percent) of Mali in 1995 to that in 1998?
Keep it short and to the point. 0.98. What is the ratio of the Emissions(in percent) of Trinidad and Tobago in 1995 to that in 1998?
Offer a terse response. 1.94. What is the ratio of the Emissions(in percent) of Israel in 1995 to that in 1999?
Offer a very short reply. 1.17. What is the ratio of the Emissions(in percent) in Lao PDR in 1995 to that in 1999?
Your response must be concise. 2.15. What is the ratio of the Emissions(in percent) of Mali in 1995 to that in 1999?
Ensure brevity in your answer.  0.98. What is the ratio of the Emissions(in percent) of Trinidad and Tobago in 1995 to that in 1999?
Offer a very short reply. 1.5. What is the ratio of the Emissions(in percent) of Israel in 1996 to that in 1997?
Your answer should be very brief. 1.03. What is the ratio of the Emissions(in percent) in Lao PDR in 1996 to that in 1997?
Provide a short and direct response. 1.19. What is the ratio of the Emissions(in percent) of Mali in 1996 to that in 1997?
Provide a short and direct response. 1.01. What is the ratio of the Emissions(in percent) in Trinidad and Tobago in 1996 to that in 1997?
Offer a very short reply. 1.15. What is the ratio of the Emissions(in percent) of Israel in 1996 to that in 1998?
Offer a terse response. 1.09. What is the ratio of the Emissions(in percent) in Lao PDR in 1996 to that in 1998?
Provide a succinct answer. 1.28. What is the ratio of the Emissions(in percent) of Trinidad and Tobago in 1996 to that in 1998?
Offer a terse response. 1.32. What is the ratio of the Emissions(in percent) in Israel in 1996 to that in 1999?
Keep it short and to the point. 1.09. What is the ratio of the Emissions(in percent) of Lao PDR in 1996 to that in 1999?
Ensure brevity in your answer.  1.7. What is the ratio of the Emissions(in percent) of Mali in 1996 to that in 1999?
Provide a succinct answer. 0.98. What is the ratio of the Emissions(in percent) in Trinidad and Tobago in 1996 to that in 1999?
Provide a succinct answer. 1.02. What is the ratio of the Emissions(in percent) of Israel in 1997 to that in 1998?
Provide a short and direct response. 1.06. What is the ratio of the Emissions(in percent) in Lao PDR in 1997 to that in 1998?
Provide a succinct answer. 1.07. What is the ratio of the Emissions(in percent) of Trinidad and Tobago in 1997 to that in 1998?
Provide a succinct answer. 1.15. What is the ratio of the Emissions(in percent) in Israel in 1997 to that in 1999?
Your answer should be very brief. 1.06. What is the ratio of the Emissions(in percent) of Lao PDR in 1997 to that in 1999?
Ensure brevity in your answer.  1.43. What is the ratio of the Emissions(in percent) of Trinidad and Tobago in 1997 to that in 1999?
Provide a succinct answer. 0.88. What is the ratio of the Emissions(in percent) in Israel in 1998 to that in 1999?
Ensure brevity in your answer.  1. What is the ratio of the Emissions(in percent) in Lao PDR in 1998 to that in 1999?
Provide a succinct answer. 1.33. What is the ratio of the Emissions(in percent) in Trinidad and Tobago in 1998 to that in 1999?
Your response must be concise. 0.77. What is the difference between the highest and the second highest Emissions(in percent) in Israel?
Keep it short and to the point. 0.57. What is the difference between the highest and the second highest Emissions(in percent) in Lao PDR?
Make the answer very short. 1.12. What is the difference between the highest and the second highest Emissions(in percent) of Trinidad and Tobago?
Offer a terse response. 3.52. What is the difference between the highest and the lowest Emissions(in percent) of Israel?
Keep it short and to the point. 11.03. What is the difference between the highest and the lowest Emissions(in percent) in Lao PDR?
Your answer should be very brief. 60.37. What is the difference between the highest and the lowest Emissions(in percent) of Mali?
Provide a short and direct response. 2.8. What is the difference between the highest and the lowest Emissions(in percent) of Trinidad and Tobago?
Offer a very short reply. 13.37. 